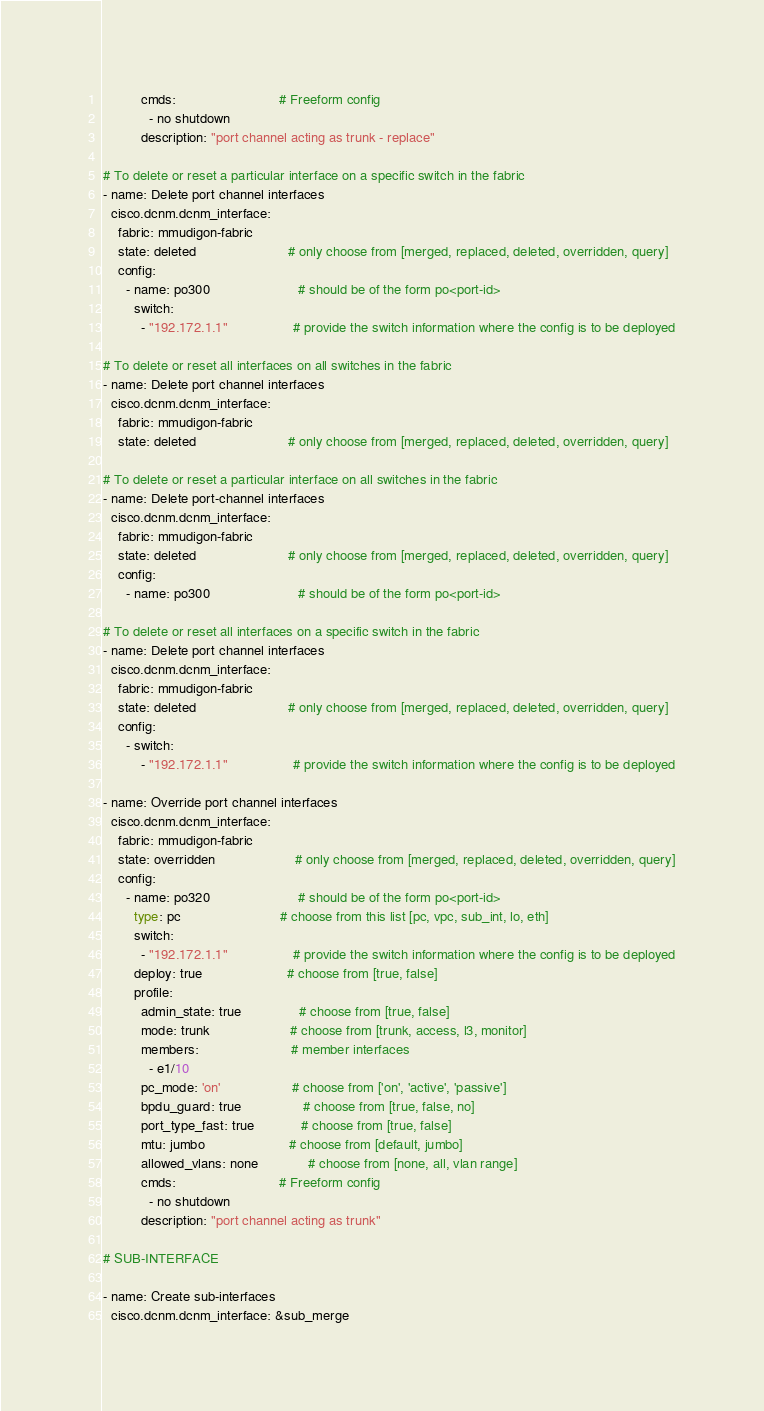Convert code to text. <code><loc_0><loc_0><loc_500><loc_500><_Python_>          cmds:                           # Freeform config
            - no shutdown
          description: "port channel acting as trunk - replace"

# To delete or reset a particular interface on a specific switch in the fabric
- name: Delete port channel interfaces
  cisco.dcnm.dcnm_interface:
    fabric: mmudigon-fabric
    state: deleted                        # only choose from [merged, replaced, deleted, overridden, query]
    config:
      - name: po300                       # should be of the form po<port-id>
        switch:
          - "192.172.1.1"                 # provide the switch information where the config is to be deployed

# To delete or reset all interfaces on all switches in the fabric
- name: Delete port channel interfaces
  cisco.dcnm.dcnm_interface:
    fabric: mmudigon-fabric
    state: deleted                        # only choose from [merged, replaced, deleted, overridden, query]

# To delete or reset a particular interface on all switches in the fabric
- name: Delete port-channel interfaces
  cisco.dcnm.dcnm_interface:
    fabric: mmudigon-fabric
    state: deleted                        # only choose from [merged, replaced, deleted, overridden, query]
    config:
      - name: po300                       # should be of the form po<port-id>

# To delete or reset all interfaces on a specific switch in the fabric
- name: Delete port channel interfaces
  cisco.dcnm.dcnm_interface:
    fabric: mmudigon-fabric
    state: deleted                        # only choose from [merged, replaced, deleted, overridden, query]
    config:
      - switch:
          - "192.172.1.1"                 # provide the switch information where the config is to be deployed

- name: Override port channel interfaces
  cisco.dcnm.dcnm_interface:
    fabric: mmudigon-fabric
    state: overridden                     # only choose from [merged, replaced, deleted, overridden, query]
    config:
      - name: po320                       # should be of the form po<port-id>
        type: pc                          # choose from this list [pc, vpc, sub_int, lo, eth]
        switch:
          - "192.172.1.1"                 # provide the switch information where the config is to be deployed
        deploy: true                      # choose from [true, false]
        profile:
          admin_state: true               # choose from [true, false]
          mode: trunk                     # choose from [trunk, access, l3, monitor]
          members:                        # member interfaces
            - e1/10
          pc_mode: 'on'                   # choose from ['on', 'active', 'passive']
          bpdu_guard: true                # choose from [true, false, no]
          port_type_fast: true            # choose from [true, false]
          mtu: jumbo                      # choose from [default, jumbo]
          allowed_vlans: none             # choose from [none, all, vlan range]
          cmds:                           # Freeform config
            - no shutdown
          description: "port channel acting as trunk"

# SUB-INTERFACE

- name: Create sub-interfaces
  cisco.dcnm.dcnm_interface: &sub_merge</code> 